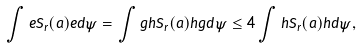Convert formula to latex. <formula><loc_0><loc_0><loc_500><loc_500>\int e S _ { r } ( a ) e d \psi = \int g h S _ { r } ( a ) h g d \psi \leq 4 \int h S _ { r } ( a ) h d \psi ,</formula> 